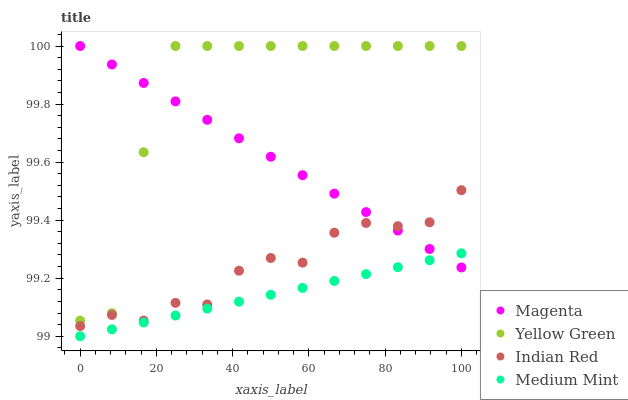Does Medium Mint have the minimum area under the curve?
Answer yes or no. Yes. Does Yellow Green have the maximum area under the curve?
Answer yes or no. Yes. Does Magenta have the minimum area under the curve?
Answer yes or no. No. Does Magenta have the maximum area under the curve?
Answer yes or no. No. Is Magenta the smoothest?
Answer yes or no. Yes. Is Yellow Green the roughest?
Answer yes or no. Yes. Is Yellow Green the smoothest?
Answer yes or no. No. Is Magenta the roughest?
Answer yes or no. No. Does Medium Mint have the lowest value?
Answer yes or no. Yes. Does Yellow Green have the lowest value?
Answer yes or no. No. Does Yellow Green have the highest value?
Answer yes or no. Yes. Does Indian Red have the highest value?
Answer yes or no. No. Is Medium Mint less than Indian Red?
Answer yes or no. Yes. Is Yellow Green greater than Indian Red?
Answer yes or no. Yes. Does Yellow Green intersect Magenta?
Answer yes or no. Yes. Is Yellow Green less than Magenta?
Answer yes or no. No. Is Yellow Green greater than Magenta?
Answer yes or no. No. Does Medium Mint intersect Indian Red?
Answer yes or no. No. 